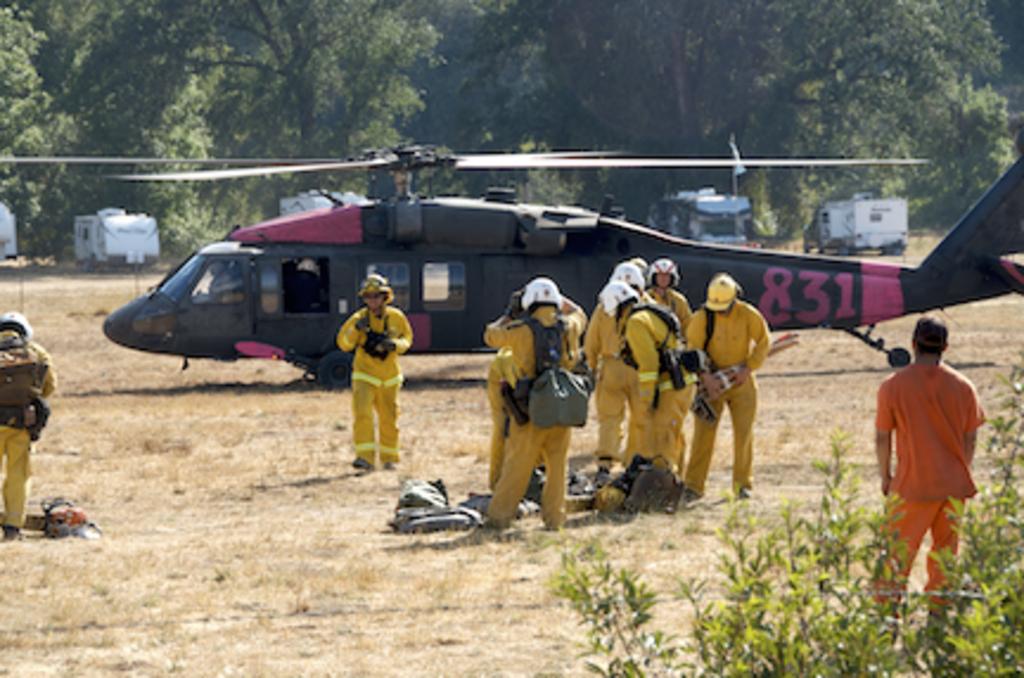What is the heliocopters id number?
Your answer should be compact. 831. What number is on the helicopter?/?
Offer a terse response. 831. 